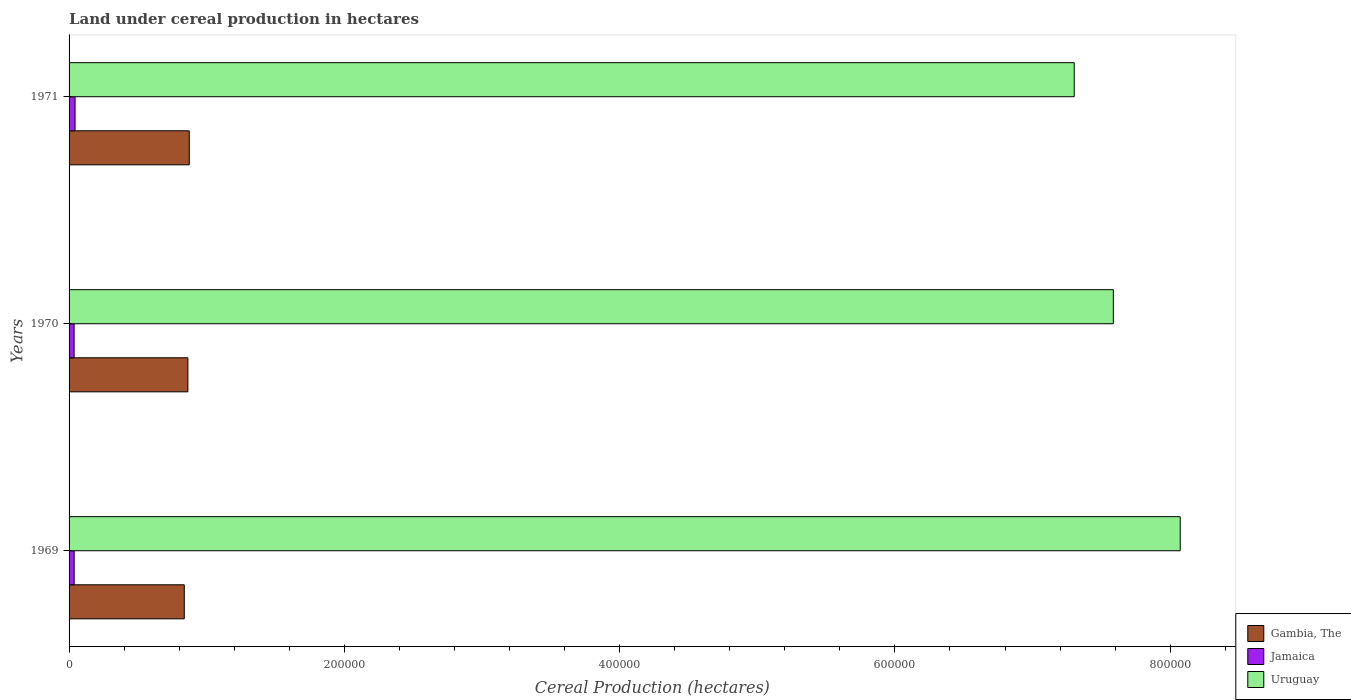How many groups of bars are there?
Keep it short and to the point. 3. What is the land under cereal production in Jamaica in 1969?
Provide a succinct answer. 3710. Across all years, what is the maximum land under cereal production in Uruguay?
Your answer should be very brief. 8.07e+05. Across all years, what is the minimum land under cereal production in Gambia, The?
Your answer should be very brief. 8.37e+04. What is the total land under cereal production in Uruguay in the graph?
Your answer should be compact. 2.30e+06. What is the difference between the land under cereal production in Gambia, The in 1970 and the land under cereal production in Uruguay in 1969?
Provide a succinct answer. -7.21e+05. What is the average land under cereal production in Gambia, The per year?
Offer a terse response. 8.58e+04. In the year 1970, what is the difference between the land under cereal production in Jamaica and land under cereal production in Gambia, The?
Offer a terse response. -8.27e+04. What is the ratio of the land under cereal production in Uruguay in 1970 to that in 1971?
Give a very brief answer. 1.04. What is the difference between the highest and the second highest land under cereal production in Gambia, The?
Your response must be concise. 1000. What is the difference between the highest and the lowest land under cereal production in Gambia, The?
Make the answer very short. 3618. In how many years, is the land under cereal production in Jamaica greater than the average land under cereal production in Jamaica taken over all years?
Ensure brevity in your answer.  1. Is the sum of the land under cereal production in Uruguay in 1969 and 1971 greater than the maximum land under cereal production in Gambia, The across all years?
Your answer should be very brief. Yes. What does the 2nd bar from the top in 1970 represents?
Your response must be concise. Jamaica. What does the 1st bar from the bottom in 1969 represents?
Your answer should be very brief. Gambia, The. How many years are there in the graph?
Provide a short and direct response. 3. What is the difference between two consecutive major ticks on the X-axis?
Your answer should be compact. 2.00e+05. Are the values on the major ticks of X-axis written in scientific E-notation?
Provide a short and direct response. No. Does the graph contain any zero values?
Your response must be concise. No. How many legend labels are there?
Your answer should be compact. 3. What is the title of the graph?
Your answer should be compact. Land under cereal production in hectares. Does "Saudi Arabia" appear as one of the legend labels in the graph?
Give a very brief answer. No. What is the label or title of the X-axis?
Provide a succinct answer. Cereal Production (hectares). What is the Cereal Production (hectares) in Gambia, The in 1969?
Give a very brief answer. 8.37e+04. What is the Cereal Production (hectares) of Jamaica in 1969?
Your answer should be very brief. 3710. What is the Cereal Production (hectares) in Uruguay in 1969?
Give a very brief answer. 8.07e+05. What is the Cereal Production (hectares) in Gambia, The in 1970?
Keep it short and to the point. 8.63e+04. What is the Cereal Production (hectares) in Jamaica in 1970?
Your response must be concise. 3663. What is the Cereal Production (hectares) in Uruguay in 1970?
Provide a short and direct response. 7.59e+05. What is the Cereal Production (hectares) of Gambia, The in 1971?
Provide a short and direct response. 8.73e+04. What is the Cereal Production (hectares) in Jamaica in 1971?
Offer a terse response. 4353. What is the Cereal Production (hectares) of Uruguay in 1971?
Offer a very short reply. 7.30e+05. Across all years, what is the maximum Cereal Production (hectares) of Gambia, The?
Provide a succinct answer. 8.73e+04. Across all years, what is the maximum Cereal Production (hectares) of Jamaica?
Ensure brevity in your answer.  4353. Across all years, what is the maximum Cereal Production (hectares) in Uruguay?
Give a very brief answer. 8.07e+05. Across all years, what is the minimum Cereal Production (hectares) of Gambia, The?
Your response must be concise. 8.37e+04. Across all years, what is the minimum Cereal Production (hectares) in Jamaica?
Keep it short and to the point. 3663. Across all years, what is the minimum Cereal Production (hectares) of Uruguay?
Offer a terse response. 7.30e+05. What is the total Cereal Production (hectares) in Gambia, The in the graph?
Offer a very short reply. 2.57e+05. What is the total Cereal Production (hectares) in Jamaica in the graph?
Offer a very short reply. 1.17e+04. What is the total Cereal Production (hectares) in Uruguay in the graph?
Keep it short and to the point. 2.30e+06. What is the difference between the Cereal Production (hectares) of Gambia, The in 1969 and that in 1970?
Ensure brevity in your answer.  -2618. What is the difference between the Cereal Production (hectares) in Jamaica in 1969 and that in 1970?
Your answer should be very brief. 47. What is the difference between the Cereal Production (hectares) of Uruguay in 1969 and that in 1970?
Offer a very short reply. 4.86e+04. What is the difference between the Cereal Production (hectares) in Gambia, The in 1969 and that in 1971?
Ensure brevity in your answer.  -3618. What is the difference between the Cereal Production (hectares) of Jamaica in 1969 and that in 1971?
Your response must be concise. -643. What is the difference between the Cereal Production (hectares) in Uruguay in 1969 and that in 1971?
Offer a very short reply. 7.70e+04. What is the difference between the Cereal Production (hectares) in Gambia, The in 1970 and that in 1971?
Your response must be concise. -1000. What is the difference between the Cereal Production (hectares) of Jamaica in 1970 and that in 1971?
Your answer should be compact. -690. What is the difference between the Cereal Production (hectares) in Uruguay in 1970 and that in 1971?
Keep it short and to the point. 2.84e+04. What is the difference between the Cereal Production (hectares) of Gambia, The in 1969 and the Cereal Production (hectares) of Jamaica in 1970?
Your response must be concise. 8.00e+04. What is the difference between the Cereal Production (hectares) in Gambia, The in 1969 and the Cereal Production (hectares) in Uruguay in 1970?
Provide a short and direct response. -6.75e+05. What is the difference between the Cereal Production (hectares) of Jamaica in 1969 and the Cereal Production (hectares) of Uruguay in 1970?
Offer a terse response. -7.55e+05. What is the difference between the Cereal Production (hectares) in Gambia, The in 1969 and the Cereal Production (hectares) in Jamaica in 1971?
Your answer should be very brief. 7.94e+04. What is the difference between the Cereal Production (hectares) of Gambia, The in 1969 and the Cereal Production (hectares) of Uruguay in 1971?
Offer a terse response. -6.47e+05. What is the difference between the Cereal Production (hectares) of Jamaica in 1969 and the Cereal Production (hectares) of Uruguay in 1971?
Your answer should be compact. -7.27e+05. What is the difference between the Cereal Production (hectares) in Gambia, The in 1970 and the Cereal Production (hectares) in Jamaica in 1971?
Provide a short and direct response. 8.20e+04. What is the difference between the Cereal Production (hectares) of Gambia, The in 1970 and the Cereal Production (hectares) of Uruguay in 1971?
Give a very brief answer. -6.44e+05. What is the difference between the Cereal Production (hectares) of Jamaica in 1970 and the Cereal Production (hectares) of Uruguay in 1971?
Your answer should be compact. -7.27e+05. What is the average Cereal Production (hectares) in Gambia, The per year?
Offer a very short reply. 8.58e+04. What is the average Cereal Production (hectares) in Jamaica per year?
Your answer should be very brief. 3908.67. What is the average Cereal Production (hectares) in Uruguay per year?
Give a very brief answer. 7.65e+05. In the year 1969, what is the difference between the Cereal Production (hectares) of Gambia, The and Cereal Production (hectares) of Jamaica?
Provide a succinct answer. 8.00e+04. In the year 1969, what is the difference between the Cereal Production (hectares) in Gambia, The and Cereal Production (hectares) in Uruguay?
Your answer should be compact. -7.24e+05. In the year 1969, what is the difference between the Cereal Production (hectares) in Jamaica and Cereal Production (hectares) in Uruguay?
Your response must be concise. -8.04e+05. In the year 1970, what is the difference between the Cereal Production (hectares) of Gambia, The and Cereal Production (hectares) of Jamaica?
Provide a succinct answer. 8.27e+04. In the year 1970, what is the difference between the Cereal Production (hectares) in Gambia, The and Cereal Production (hectares) in Uruguay?
Make the answer very short. -6.72e+05. In the year 1970, what is the difference between the Cereal Production (hectares) of Jamaica and Cereal Production (hectares) of Uruguay?
Offer a terse response. -7.55e+05. In the year 1971, what is the difference between the Cereal Production (hectares) in Gambia, The and Cereal Production (hectares) in Jamaica?
Ensure brevity in your answer.  8.30e+04. In the year 1971, what is the difference between the Cereal Production (hectares) in Gambia, The and Cereal Production (hectares) in Uruguay?
Provide a short and direct response. -6.43e+05. In the year 1971, what is the difference between the Cereal Production (hectares) in Jamaica and Cereal Production (hectares) in Uruguay?
Your answer should be very brief. -7.26e+05. What is the ratio of the Cereal Production (hectares) in Gambia, The in 1969 to that in 1970?
Your answer should be compact. 0.97. What is the ratio of the Cereal Production (hectares) of Jamaica in 1969 to that in 1970?
Provide a succinct answer. 1.01. What is the ratio of the Cereal Production (hectares) in Uruguay in 1969 to that in 1970?
Provide a succinct answer. 1.06. What is the ratio of the Cereal Production (hectares) in Gambia, The in 1969 to that in 1971?
Provide a short and direct response. 0.96. What is the ratio of the Cereal Production (hectares) in Jamaica in 1969 to that in 1971?
Your response must be concise. 0.85. What is the ratio of the Cereal Production (hectares) of Uruguay in 1969 to that in 1971?
Provide a succinct answer. 1.11. What is the ratio of the Cereal Production (hectares) in Jamaica in 1970 to that in 1971?
Your answer should be very brief. 0.84. What is the ratio of the Cereal Production (hectares) in Uruguay in 1970 to that in 1971?
Your response must be concise. 1.04. What is the difference between the highest and the second highest Cereal Production (hectares) in Gambia, The?
Provide a short and direct response. 1000. What is the difference between the highest and the second highest Cereal Production (hectares) in Jamaica?
Ensure brevity in your answer.  643. What is the difference between the highest and the second highest Cereal Production (hectares) of Uruguay?
Keep it short and to the point. 4.86e+04. What is the difference between the highest and the lowest Cereal Production (hectares) in Gambia, The?
Give a very brief answer. 3618. What is the difference between the highest and the lowest Cereal Production (hectares) of Jamaica?
Offer a terse response. 690. What is the difference between the highest and the lowest Cereal Production (hectares) in Uruguay?
Provide a short and direct response. 7.70e+04. 